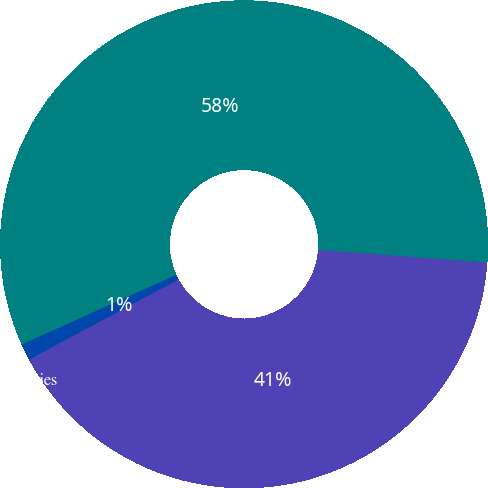<chart> <loc_0><loc_0><loc_500><loc_500><pie_chart><fcel>Interest<fcel>Income taxes including foreign<fcel>Available-for-sale securities<nl><fcel>40.99%<fcel>57.93%<fcel>1.08%<nl></chart> 